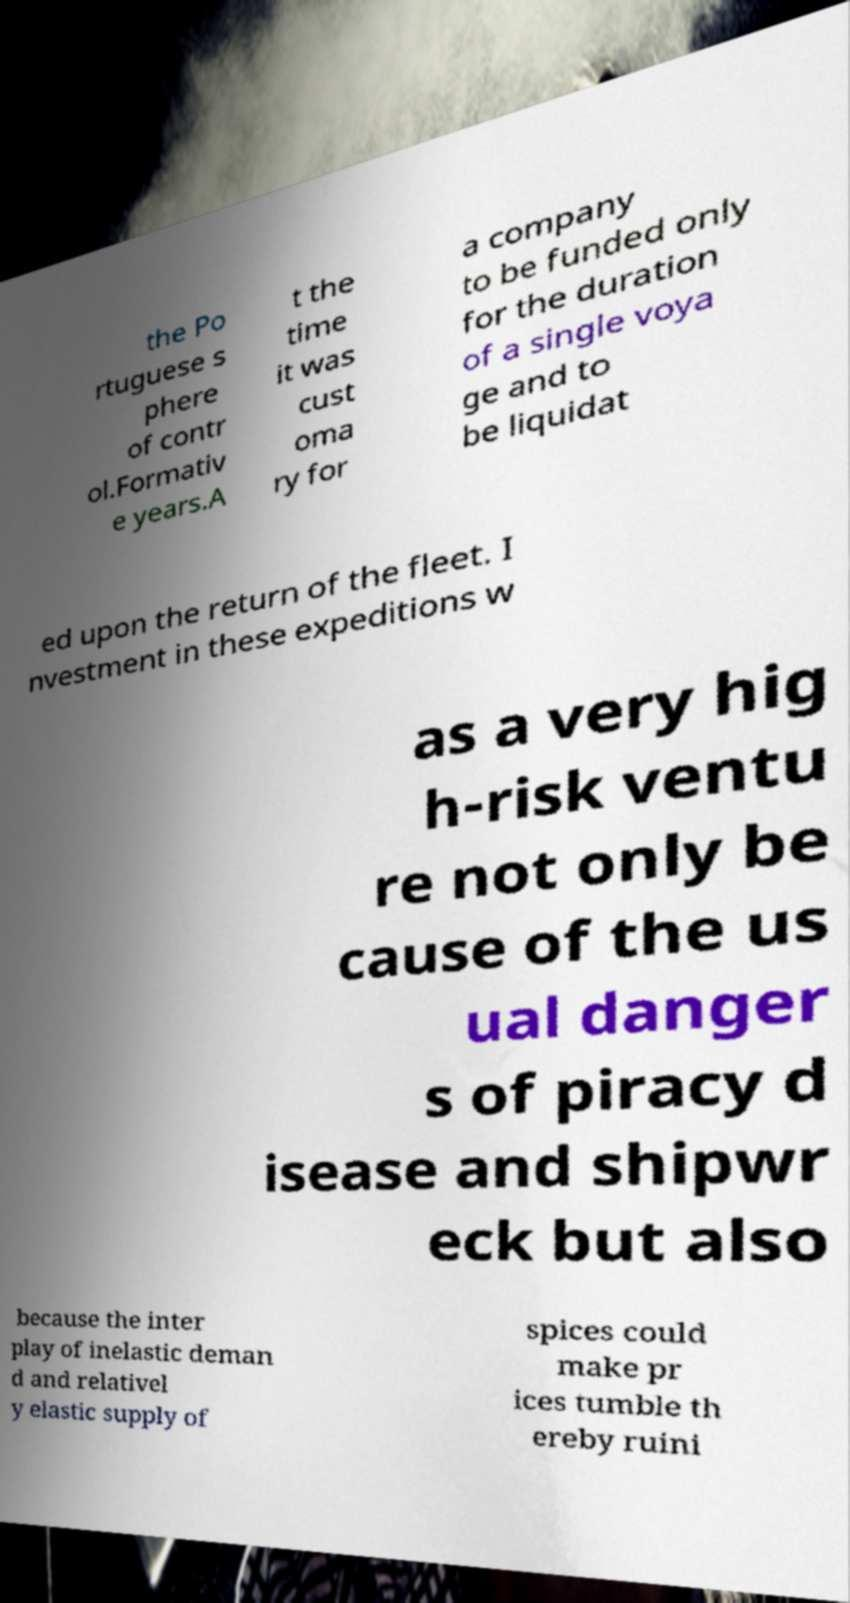Please identify and transcribe the text found in this image. the Po rtuguese s phere of contr ol.Formativ e years.A t the time it was cust oma ry for a company to be funded only for the duration of a single voya ge and to be liquidat ed upon the return of the fleet. I nvestment in these expeditions w as a very hig h-risk ventu re not only be cause of the us ual danger s of piracy d isease and shipwr eck but also because the inter play of inelastic deman d and relativel y elastic supply of spices could make pr ices tumble th ereby ruini 